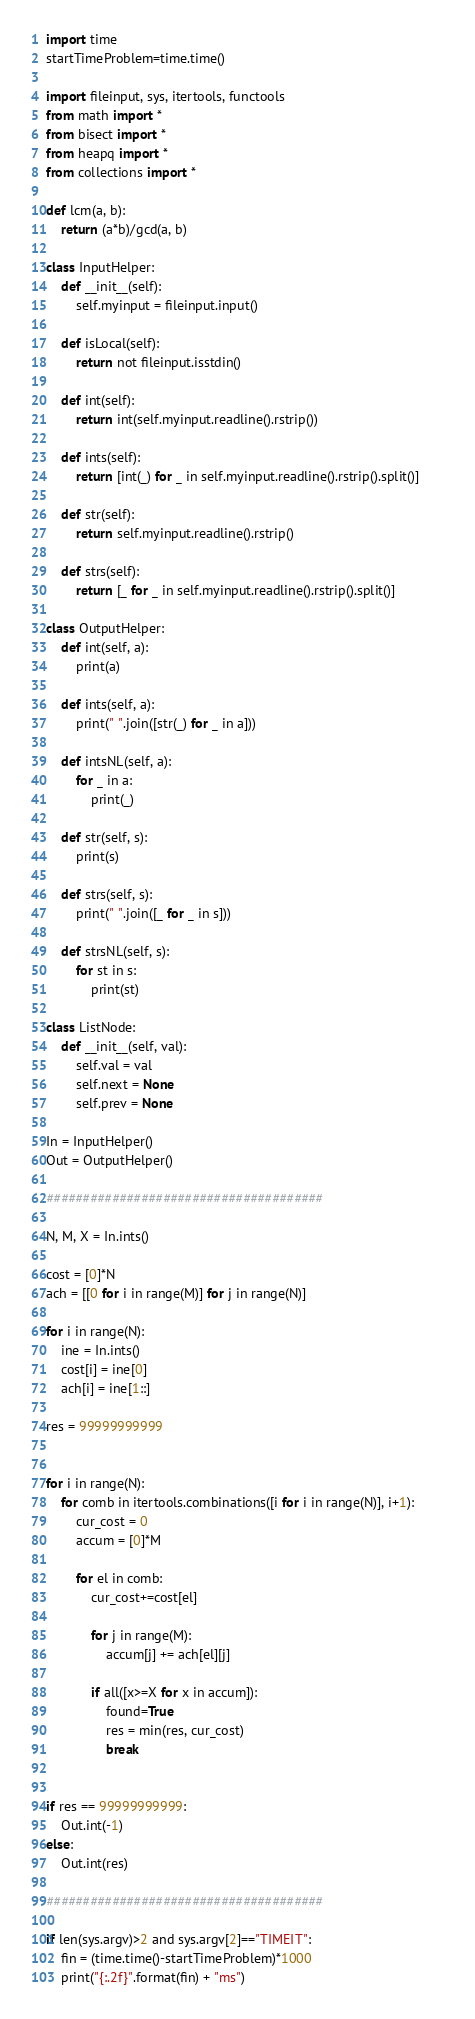<code> <loc_0><loc_0><loc_500><loc_500><_Python_>import time
startTimeProblem=time.time()

import fileinput, sys, itertools, functools
from math import *
from bisect import *
from heapq import *
from collections import *

def lcm(a, b):  
    return (a*b)/gcd(a, b)

class InputHelper:
    def __init__(self):
        self.myinput = fileinput.input()

    def isLocal(self):
        return not fileinput.isstdin()

    def int(self):
        return int(self.myinput.readline().rstrip())

    def ints(self):
        return [int(_) for _ in self.myinput.readline().rstrip().split()]

    def str(self):
        return self.myinput.readline().rstrip()

    def strs(self):
        return [_ for _ in self.myinput.readline().rstrip().split()]

class OutputHelper:
    def int(self, a):
        print(a)    

    def ints(self, a):  
        print(" ".join([str(_) for _ in a]))
    
    def intsNL(self, a):
        for _ in a:
            print(_)
    
    def str(self, s):
        print(s)

    def strs(self, s):
        print(" ".join([_ for _ in s]))

    def strsNL(self, s):
        for st in s:
            print(st)

class ListNode:
    def __init__(self, val):
        self.val = val
        self.next = None
        self.prev = None

In = InputHelper()
Out = OutputHelper()

######################################

N, M, X = In.ints()

cost = [0]*N
ach = [[0 for i in range(M)] for j in range(N)]

for i in range(N):
    ine = In.ints()
    cost[i] = ine[0]
    ach[i] = ine[1::]

res = 99999999999


for i in range(N):            
    for comb in itertools.combinations([i for i in range(N)], i+1):        
        cur_cost = 0
        accum = [0]*M

        for el in comb:
            cur_cost+=cost[el]

            for j in range(M):
                accum[j] += ach[el][j]

            if all([x>=X for x in accum]):
                found=True
                res = min(res, cur_cost)
                break


if res == 99999999999:
    Out.int(-1)
else:
    Out.int(res)

######################################

if len(sys.argv)>2 and sys.argv[2]=="TIMEIT":
    fin = (time.time()-startTimeProblem)*1000
    print("{:.2f}".format(fin) + "ms")</code> 